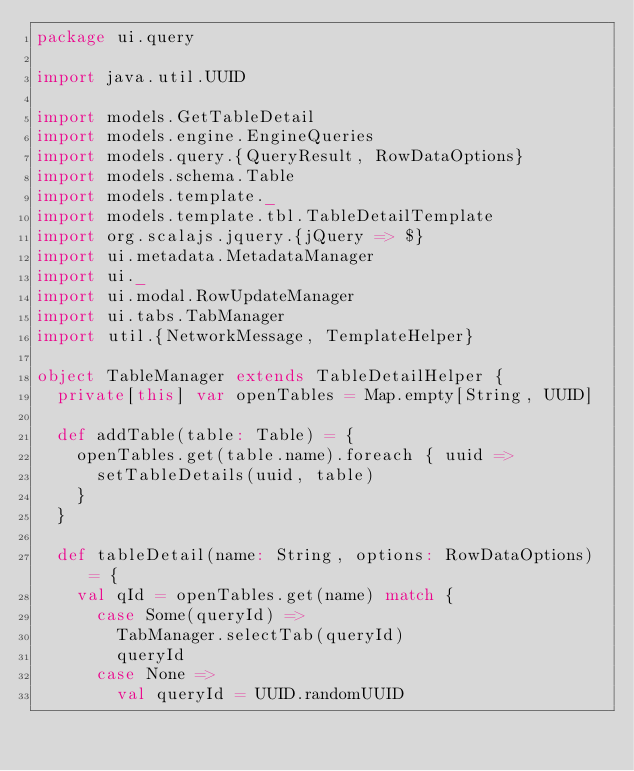<code> <loc_0><loc_0><loc_500><loc_500><_Scala_>package ui.query

import java.util.UUID

import models.GetTableDetail
import models.engine.EngineQueries
import models.query.{QueryResult, RowDataOptions}
import models.schema.Table
import models.template._
import models.template.tbl.TableDetailTemplate
import org.scalajs.jquery.{jQuery => $}
import ui.metadata.MetadataManager
import ui._
import ui.modal.RowUpdateManager
import ui.tabs.TabManager
import util.{NetworkMessage, TemplateHelper}

object TableManager extends TableDetailHelper {
  private[this] var openTables = Map.empty[String, UUID]

  def addTable(table: Table) = {
    openTables.get(table.name).foreach { uuid =>
      setTableDetails(uuid, table)
    }
  }

  def tableDetail(name: String, options: RowDataOptions) = {
    val qId = openTables.get(name) match {
      case Some(queryId) =>
        TabManager.selectTab(queryId)
        queryId
      case None =>
        val queryId = UUID.randomUUID</code> 